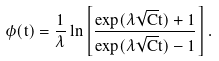Convert formula to latex. <formula><loc_0><loc_0><loc_500><loc_500>\phi ( t ) = \frac { 1 } { \lambda } \ln \left [ \frac { \exp ( \lambda \sqrt { C } t ) + 1 } { \exp ( \lambda \sqrt { C } t ) - 1 } \right ] .</formula> 